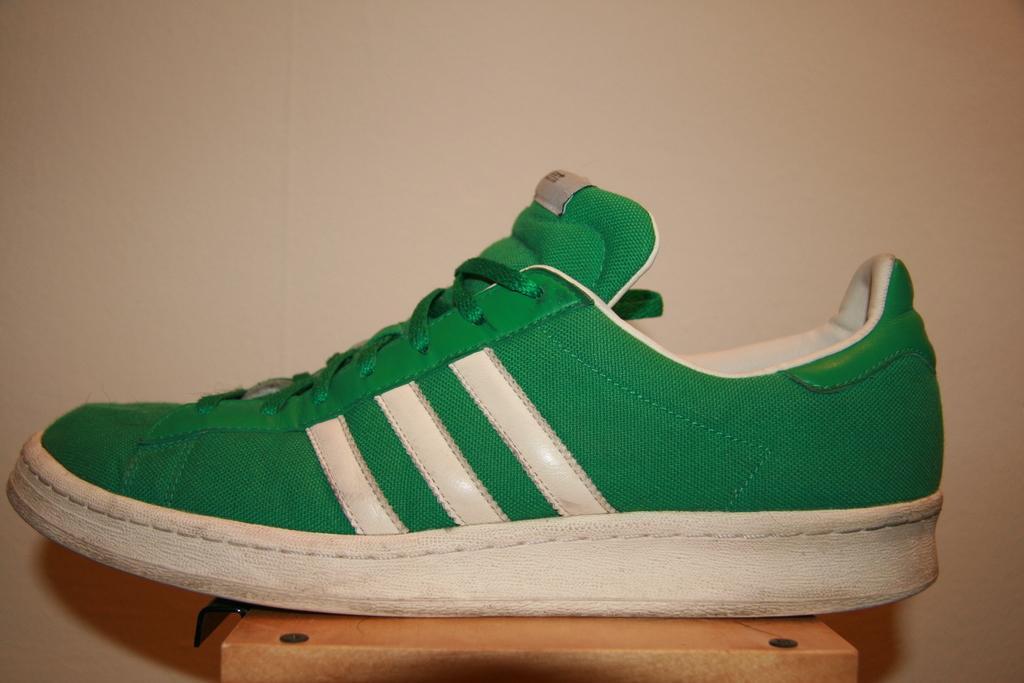In one or two sentences, can you explain what this image depicts? In this image there is a green color shoe on the wooden block. In the background there is a wall. 